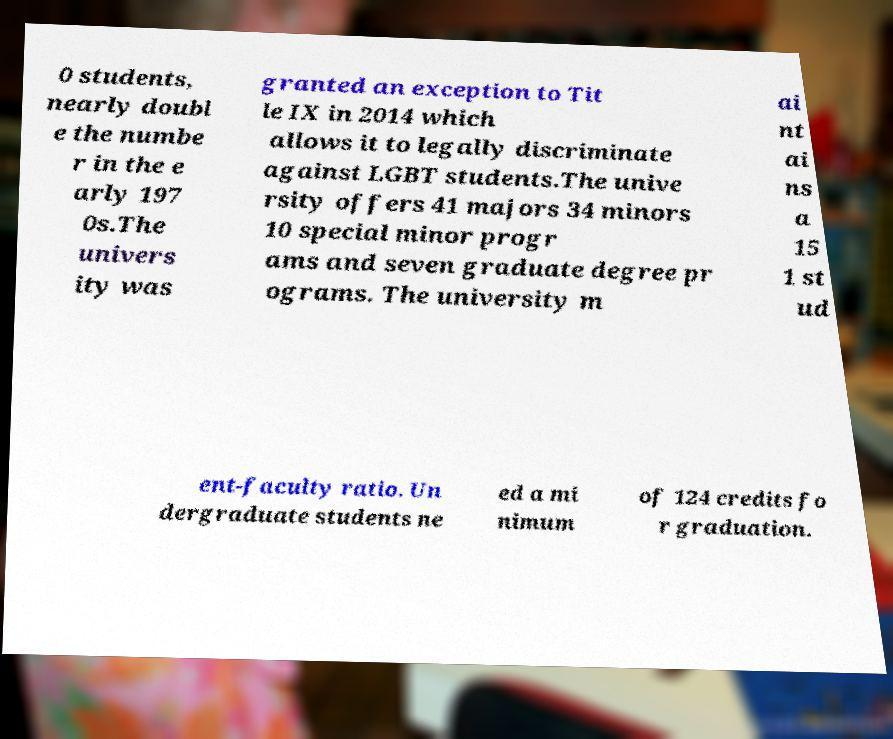What messages or text are displayed in this image? I need them in a readable, typed format. 0 students, nearly doubl e the numbe r in the e arly 197 0s.The univers ity was granted an exception to Tit le IX in 2014 which allows it to legally discriminate against LGBT students.The unive rsity offers 41 majors 34 minors 10 special minor progr ams and seven graduate degree pr ograms. The university m ai nt ai ns a 15 1 st ud ent-faculty ratio. Un dergraduate students ne ed a mi nimum of 124 credits fo r graduation. 